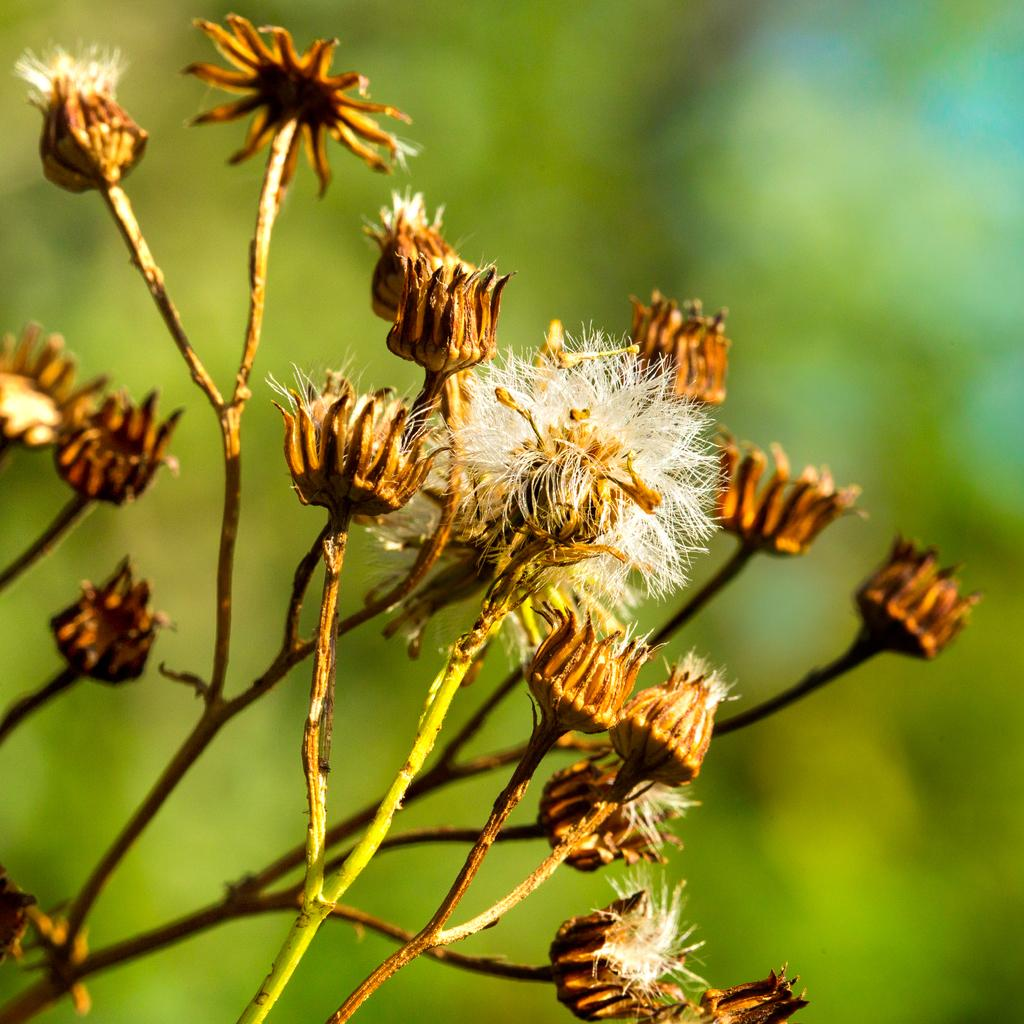Where was the image taken? The image was taken outdoors. What can be observed about the background of the image? The background of the image is blurred. What is located on the left side of the image? There is a plant on the left side of the image. How many elbows can be seen in the image? There are no elbows visible in the image. What type of beetle is crawling on the plant in the image? There is no beetle present in the image; it only features a plant. 